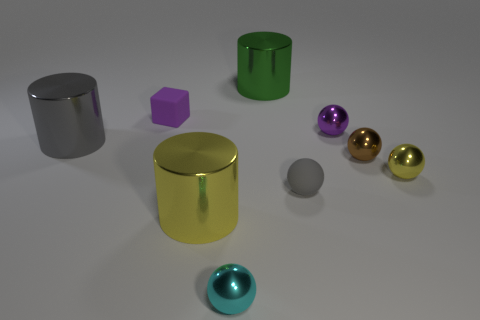How big is the matte sphere?
Your response must be concise. Small. Are there fewer small gray objects in front of the gray matte object than purple things?
Make the answer very short. Yes. How many objects have the same size as the gray rubber sphere?
Keep it short and to the point. 5. What shape is the thing that is the same color as the cube?
Give a very brief answer. Sphere. There is a tiny matte thing left of the big green object; is it the same color as the tiny shiny ball behind the large gray metal thing?
Your response must be concise. Yes. How many gray spheres are on the right side of the gray sphere?
Keep it short and to the point. 0. The sphere that is the same color as the cube is what size?
Offer a very short reply. Small. Are there any other objects of the same shape as the green metal object?
Your response must be concise. Yes. What color is the rubber cube that is the same size as the cyan thing?
Your answer should be very brief. Purple. Are there fewer brown metallic balls that are right of the small brown shiny thing than big shiny objects that are behind the small matte ball?
Your answer should be compact. Yes. 